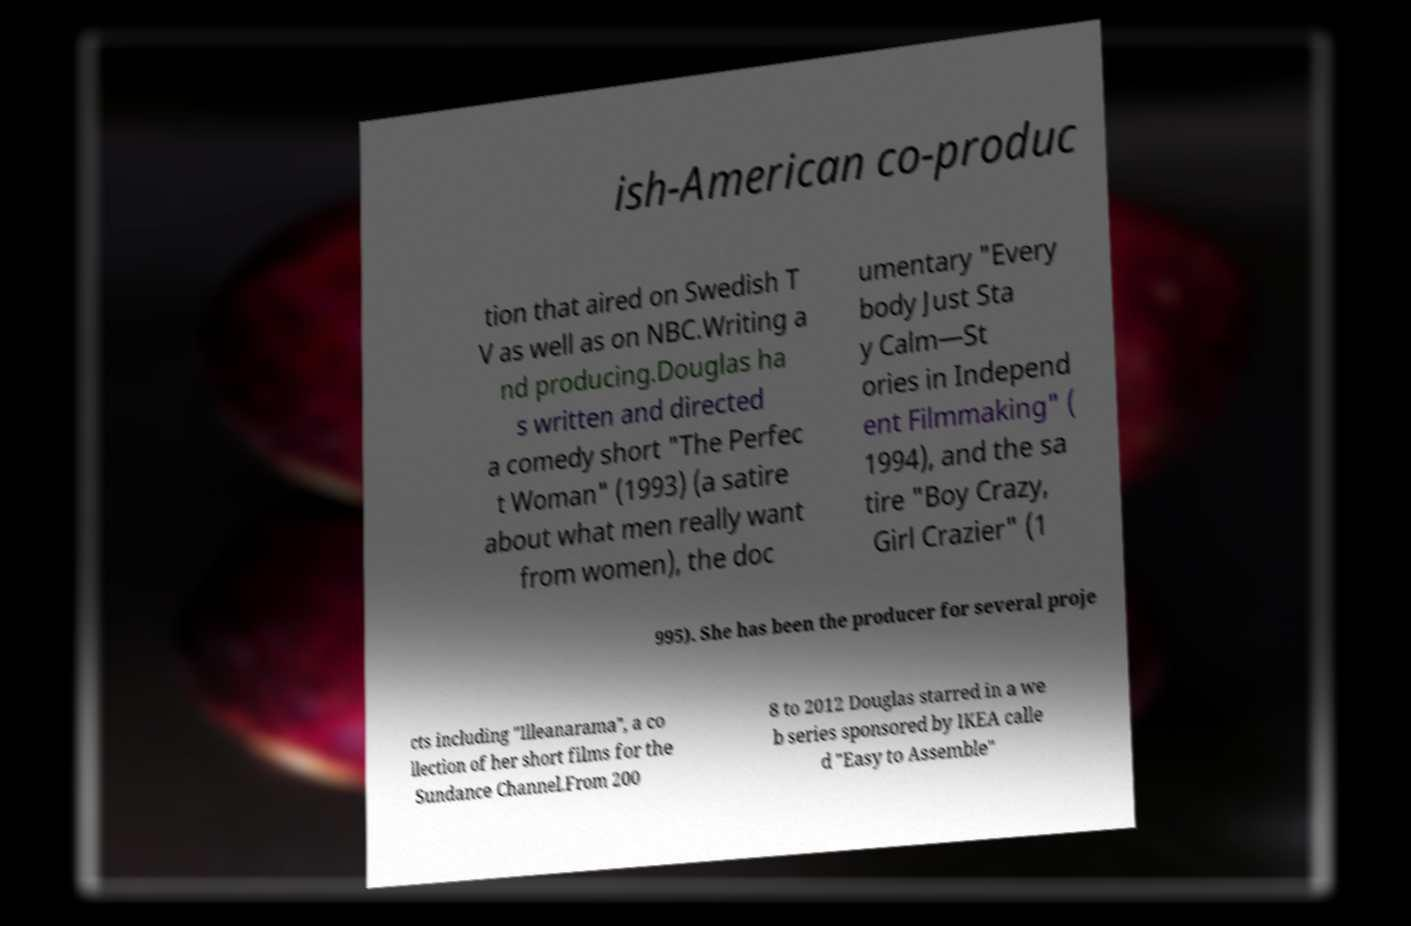For documentation purposes, I need the text within this image transcribed. Could you provide that? ish-American co-produc tion that aired on Swedish T V as well as on NBC.Writing a nd producing.Douglas ha s written and directed a comedy short "The Perfec t Woman" (1993) (a satire about what men really want from women), the doc umentary "Every body Just Sta y Calm—St ories in Independ ent Filmmaking" ( 1994), and the sa tire "Boy Crazy, Girl Crazier" (1 995). She has been the producer for several proje cts including "Illeanarama", a co llection of her short films for the Sundance Channel.From 200 8 to 2012 Douglas starred in a we b series sponsored by IKEA calle d "Easy to Assemble" 